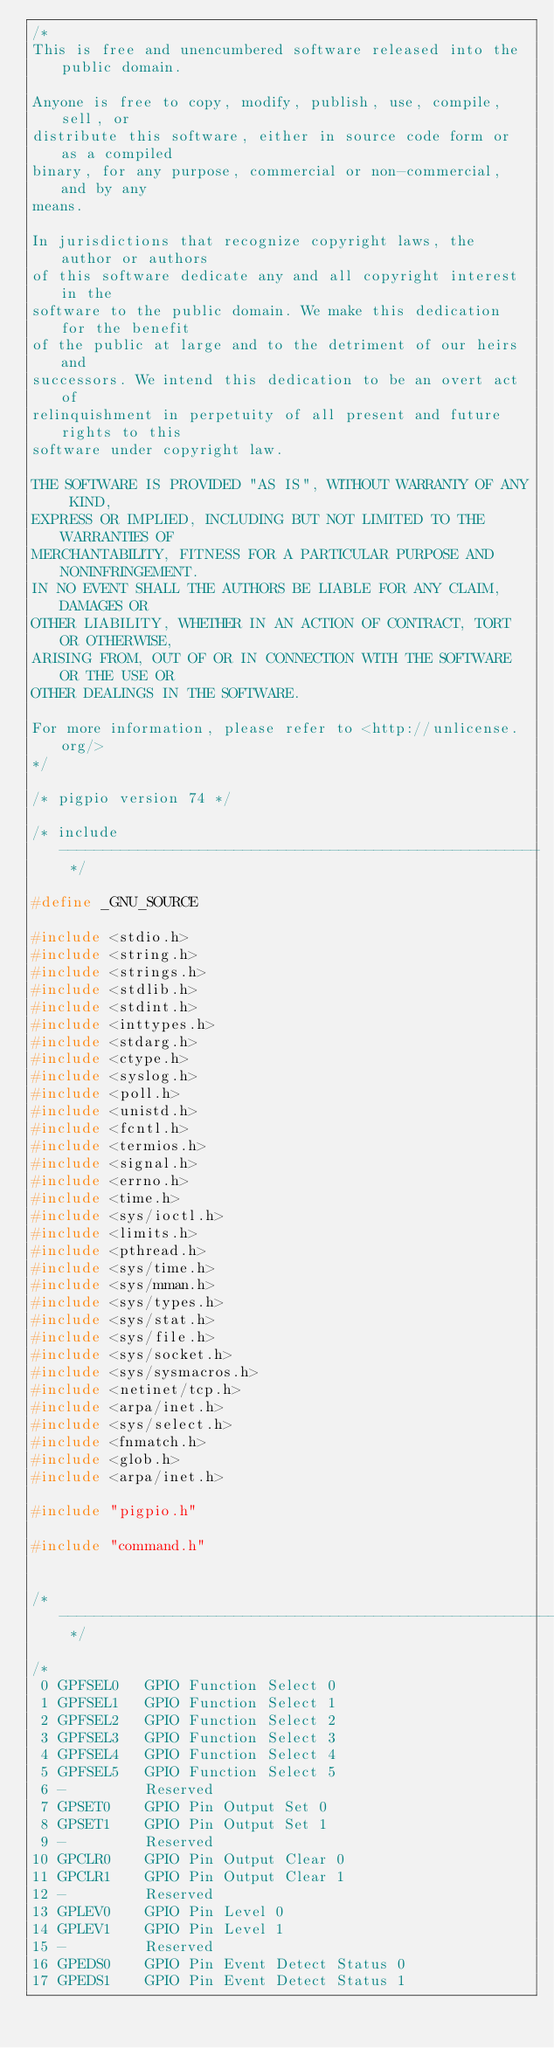<code> <loc_0><loc_0><loc_500><loc_500><_C_>/*
This is free and unencumbered software released into the public domain.

Anyone is free to copy, modify, publish, use, compile, sell, or
distribute this software, either in source code form or as a compiled
binary, for any purpose, commercial or non-commercial, and by any
means.

In jurisdictions that recognize copyright laws, the author or authors
of this software dedicate any and all copyright interest in the
software to the public domain. We make this dedication for the benefit
of the public at large and to the detriment of our heirs and
successors. We intend this dedication to be an overt act of
relinquishment in perpetuity of all present and future rights to this
software under copyright law.

THE SOFTWARE IS PROVIDED "AS IS", WITHOUT WARRANTY OF ANY KIND,
EXPRESS OR IMPLIED, INCLUDING BUT NOT LIMITED TO THE WARRANTIES OF
MERCHANTABILITY, FITNESS FOR A PARTICULAR PURPOSE AND NONINFRINGEMENT.
IN NO EVENT SHALL THE AUTHORS BE LIABLE FOR ANY CLAIM, DAMAGES OR
OTHER LIABILITY, WHETHER IN AN ACTION OF CONTRACT, TORT OR OTHERWISE,
ARISING FROM, OUT OF OR IN CONNECTION WITH THE SOFTWARE OR THE USE OR
OTHER DEALINGS IN THE SOFTWARE.

For more information, please refer to <http://unlicense.org/>
*/

/* pigpio version 74 */

/* include ------------------------------------------------------- */

#define _GNU_SOURCE

#include <stdio.h>
#include <string.h>
#include <strings.h>
#include <stdlib.h>
#include <stdint.h>
#include <inttypes.h>
#include <stdarg.h>
#include <ctype.h>
#include <syslog.h>
#include <poll.h>
#include <unistd.h>
#include <fcntl.h>
#include <termios.h>
#include <signal.h>
#include <errno.h>
#include <time.h>
#include <sys/ioctl.h>
#include <limits.h>
#include <pthread.h>
#include <sys/time.h>
#include <sys/mman.h>
#include <sys/types.h>
#include <sys/stat.h>
#include <sys/file.h>
#include <sys/socket.h>
#include <sys/sysmacros.h>
#include <netinet/tcp.h>
#include <arpa/inet.h>
#include <sys/select.h>
#include <fnmatch.h>
#include <glob.h>
#include <arpa/inet.h>

#include "pigpio.h"

#include "command.h"


/* --------------------------------------------------------------- */

/*
 0 GPFSEL0   GPIO Function Select 0
 1 GPFSEL1   GPIO Function Select 1
 2 GPFSEL2   GPIO Function Select 2
 3 GPFSEL3   GPIO Function Select 3
 4 GPFSEL4   GPIO Function Select 4
 5 GPFSEL5   GPIO Function Select 5
 6 -         Reserved
 7 GPSET0    GPIO Pin Output Set 0
 8 GPSET1    GPIO Pin Output Set 1
 9 -         Reserved
10 GPCLR0    GPIO Pin Output Clear 0
11 GPCLR1    GPIO Pin Output Clear 1
12 -         Reserved
13 GPLEV0    GPIO Pin Level 0
14 GPLEV1    GPIO Pin Level 1
15 -         Reserved
16 GPEDS0    GPIO Pin Event Detect Status 0
17 GPEDS1    GPIO Pin Event Detect Status 1</code> 